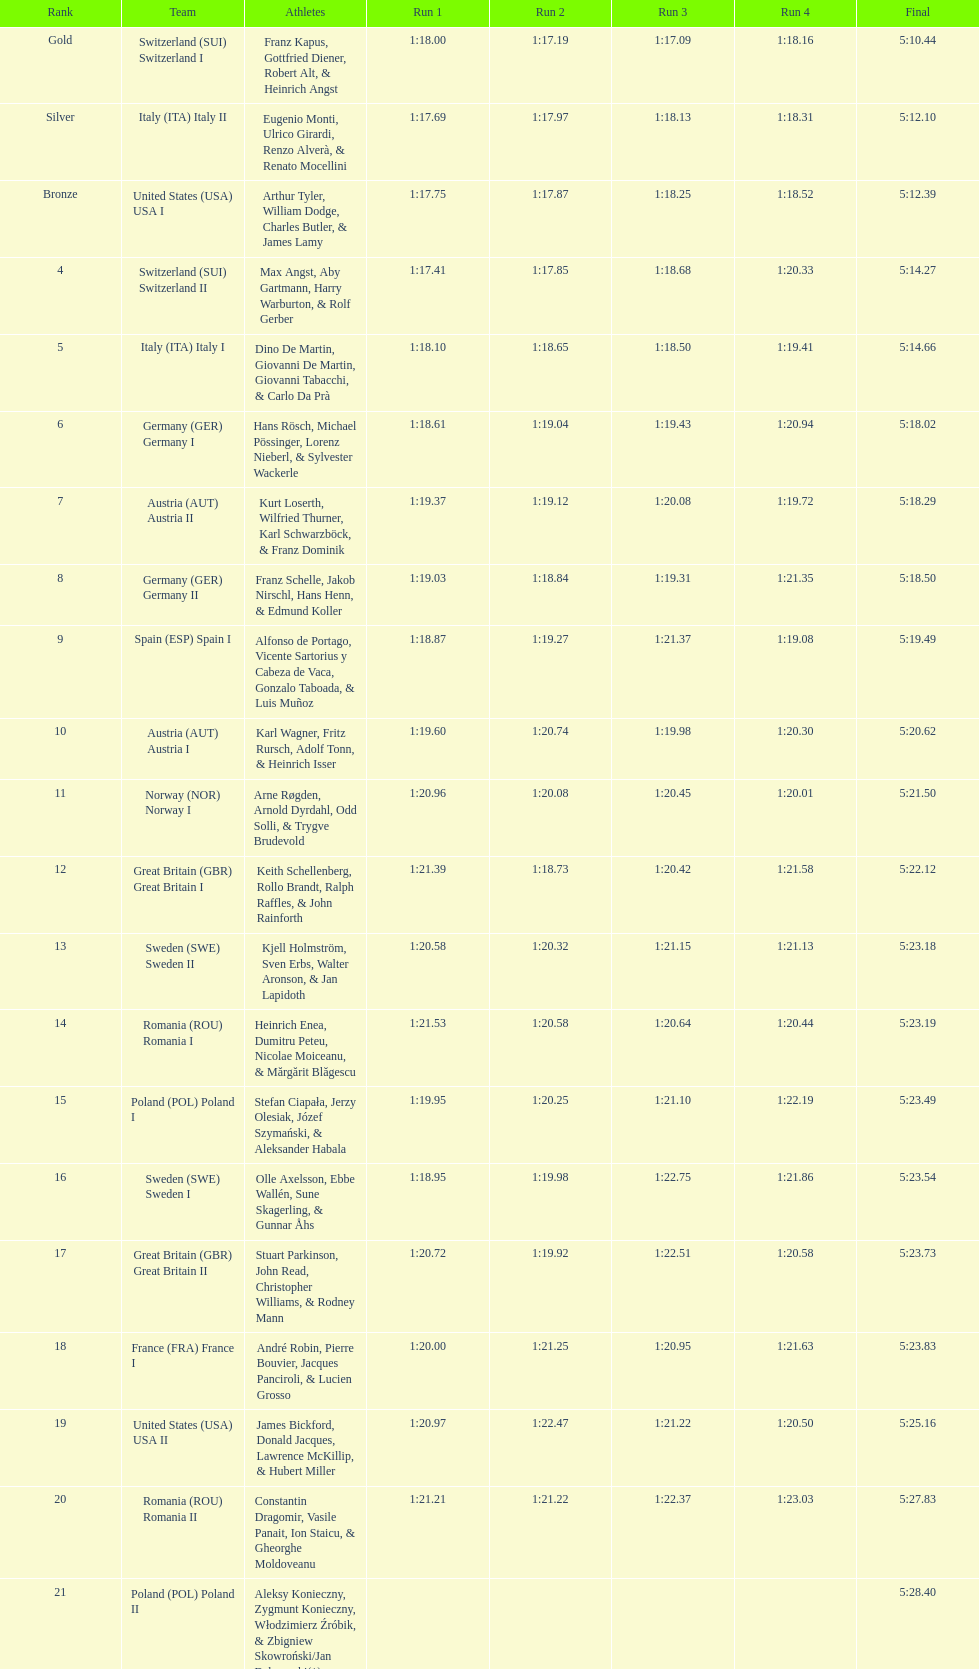Who was the team before italy (ita) italy ii? Switzerland (SUI) Switzerland I. 